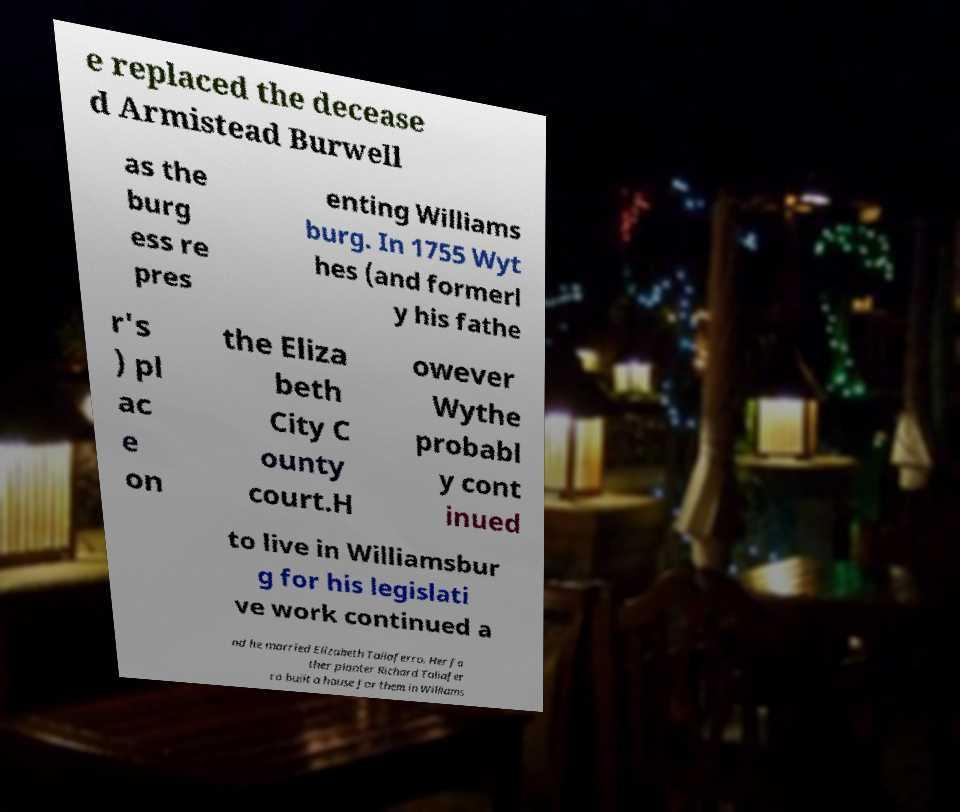Could you extract and type out the text from this image? e replaced the decease d Armistead Burwell as the burg ess re pres enting Williams burg. In 1755 Wyt hes (and formerl y his fathe r's ) pl ac e on the Eliza beth City C ounty court.H owever Wythe probabl y cont inued to live in Williamsbur g for his legislati ve work continued a nd he married Elizabeth Taliaferro. Her fa ther planter Richard Taliafer ro built a house for them in Williams 